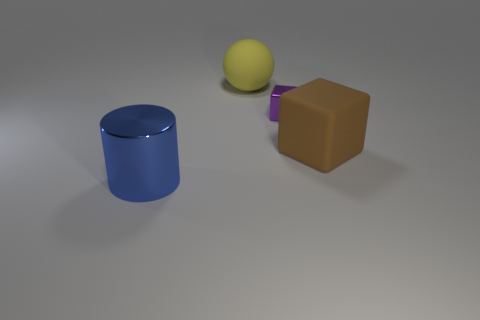Add 4 tiny cyan things. How many objects exist? 8 Subtract all purple cubes. How many cubes are left? 1 Subtract 1 cylinders. How many cylinders are left? 0 Subtract all gray cylinders. Subtract all gray cubes. How many cylinders are left? 1 Subtract all purple cylinders. How many purple blocks are left? 1 Subtract all big yellow shiny things. Subtract all purple shiny things. How many objects are left? 3 Add 1 big yellow balls. How many big yellow balls are left? 2 Add 4 tiny yellow metallic objects. How many tiny yellow metallic objects exist? 4 Subtract 0 yellow cubes. How many objects are left? 4 Subtract all spheres. How many objects are left? 3 